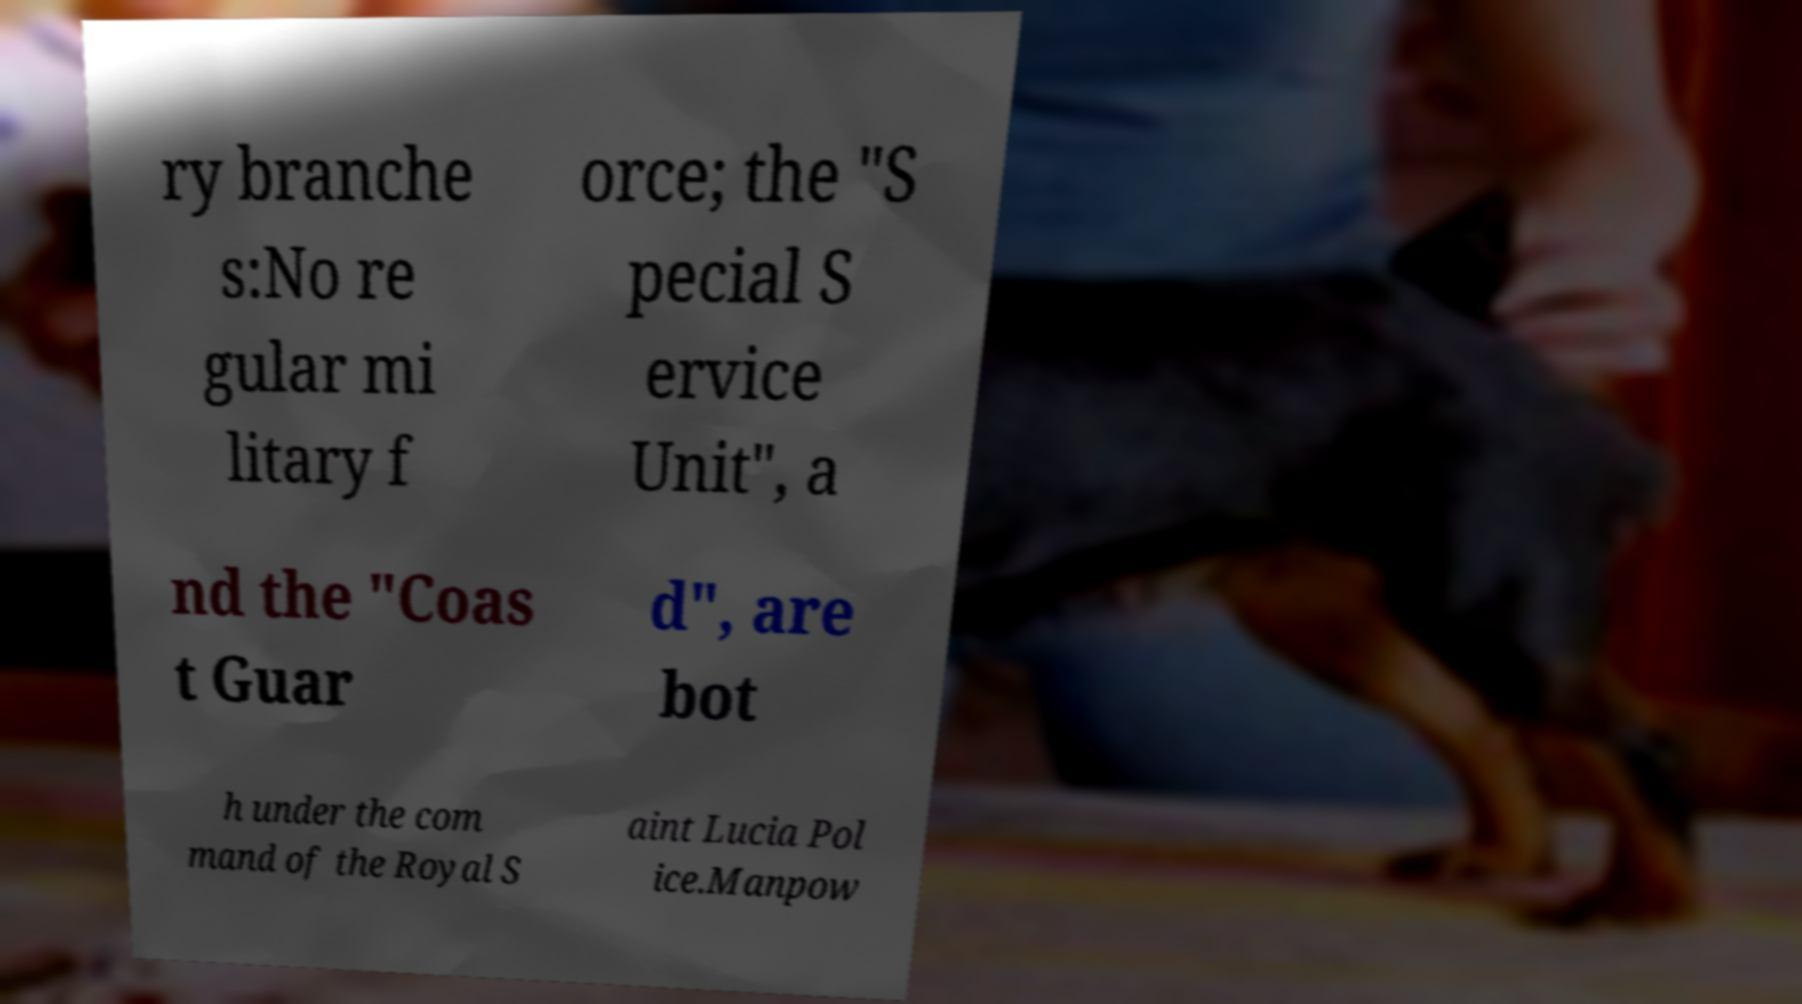Can you read and provide the text displayed in the image?This photo seems to have some interesting text. Can you extract and type it out for me? ry branche s:No re gular mi litary f orce; the "S pecial S ervice Unit", a nd the "Coas t Guar d", are bot h under the com mand of the Royal S aint Lucia Pol ice.Manpow 